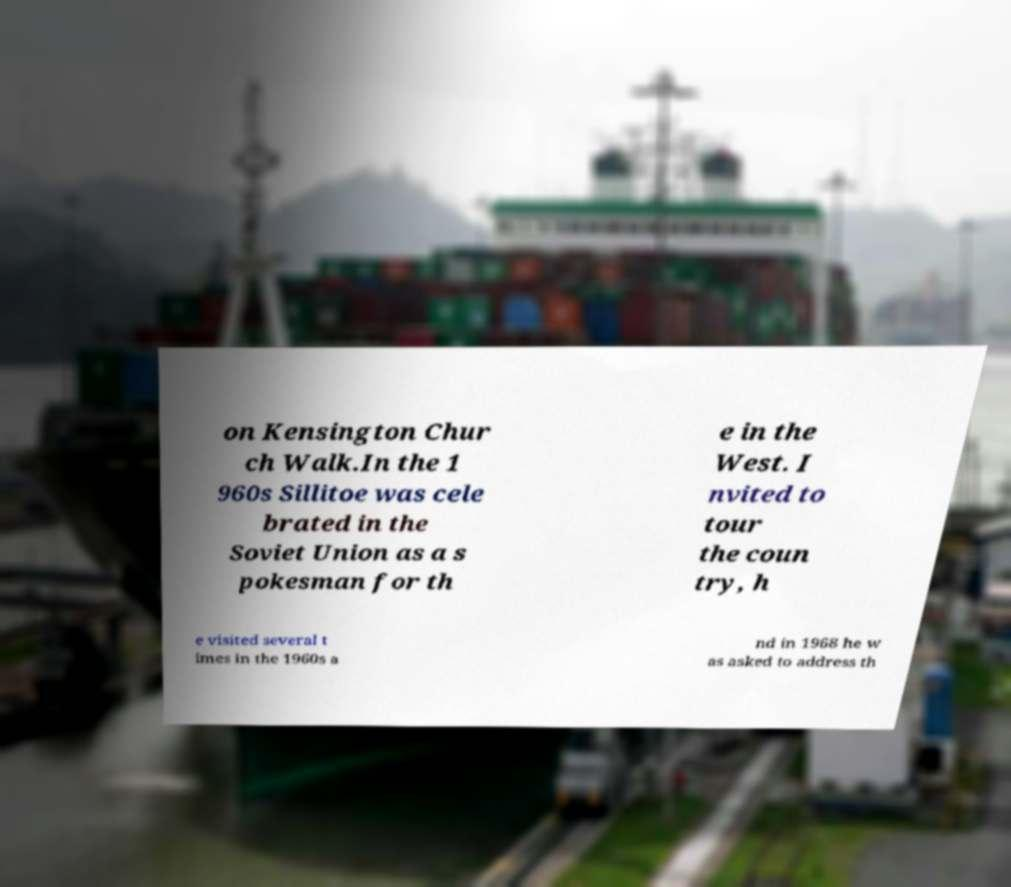Please identify and transcribe the text found in this image. on Kensington Chur ch Walk.In the 1 960s Sillitoe was cele brated in the Soviet Union as a s pokesman for th e in the West. I nvited to tour the coun try, h e visited several t imes in the 1960s a nd in 1968 he w as asked to address th 